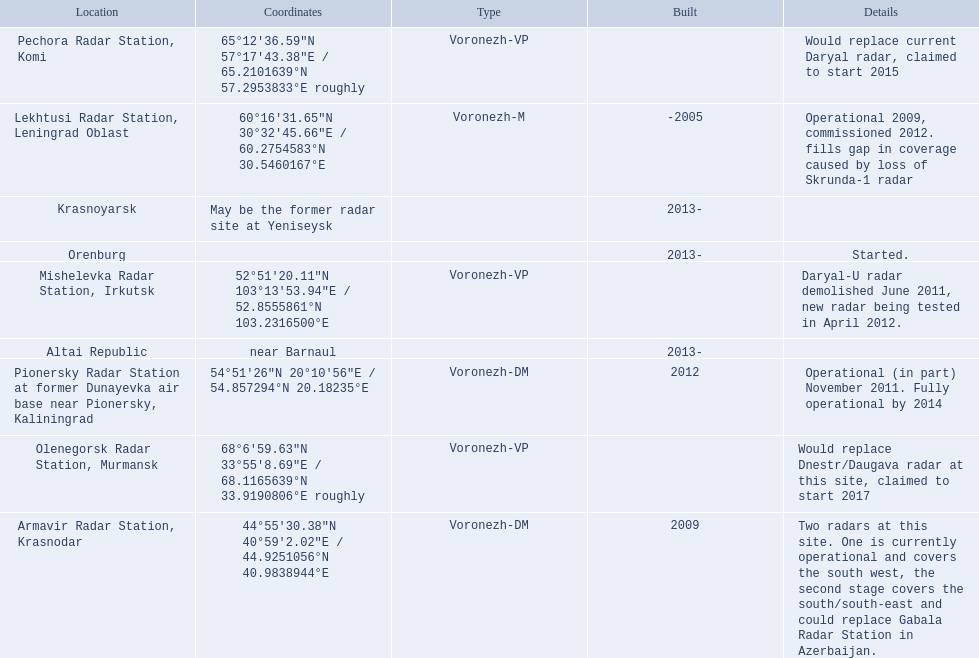What are the list of radar locations? Lekhtusi Radar Station, Leningrad Oblast, Armavir Radar Station, Krasnodar, Pionersky Radar Station at former Dunayevka air base near Pionersky, Kaliningrad, Mishelevka Radar Station, Irkutsk, Pechora Radar Station, Komi, Olenegorsk Radar Station, Murmansk, Krasnoyarsk, Altai Republic, Orenburg. Which of these are claimed to start in 2015? Pechora Radar Station, Komi. 